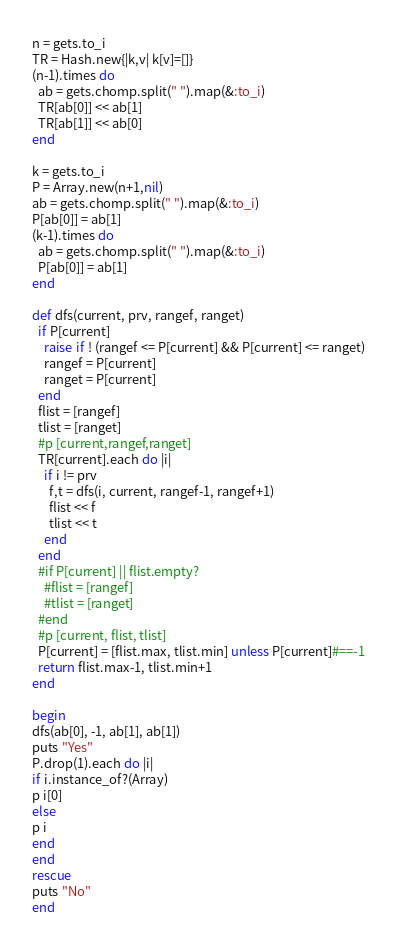Convert code to text. <code><loc_0><loc_0><loc_500><loc_500><_Ruby_>n = gets.to_i
TR = Hash.new{|k,v| k[v]=[]}
(n-1).times do
  ab = gets.chomp.split(" ").map(&:to_i)
  TR[ab[0]] << ab[1]
  TR[ab[1]] << ab[0]
end

k = gets.to_i
P = Array.new(n+1,nil)
ab = gets.chomp.split(" ").map(&:to_i)
P[ab[0]] = ab[1]
(k-1).times do
  ab = gets.chomp.split(" ").map(&:to_i)
  P[ab[0]] = ab[1]
end

def dfs(current, prv, rangef, ranget)
  if P[current]
    raise if ! (rangef <= P[current] && P[current] <= ranget)
    rangef = P[current]
    ranget = P[current]
  end
  flist = [rangef]
  tlist = [ranget]
  #p [current,rangef,ranget]
  TR[current].each do |i|
    if i != prv
      f,t = dfs(i, current, rangef-1, rangef+1)
      flist << f
      tlist << t
    end
  end
  #if P[current] || flist.empty?
    #flist = [rangef]
    #tlist = [ranget]
  #end
  #p [current, flist, tlist]
  P[current] = [flist.max, tlist.min] unless P[current]#==-1
  return flist.max-1, tlist.min+1
end

begin
dfs(ab[0], -1, ab[1], ab[1])
puts "Yes"
P.drop(1).each do |i|
if i.instance_of?(Array)
p i[0]
else
p i
end
end
rescue
puts "No"
end
</code> 